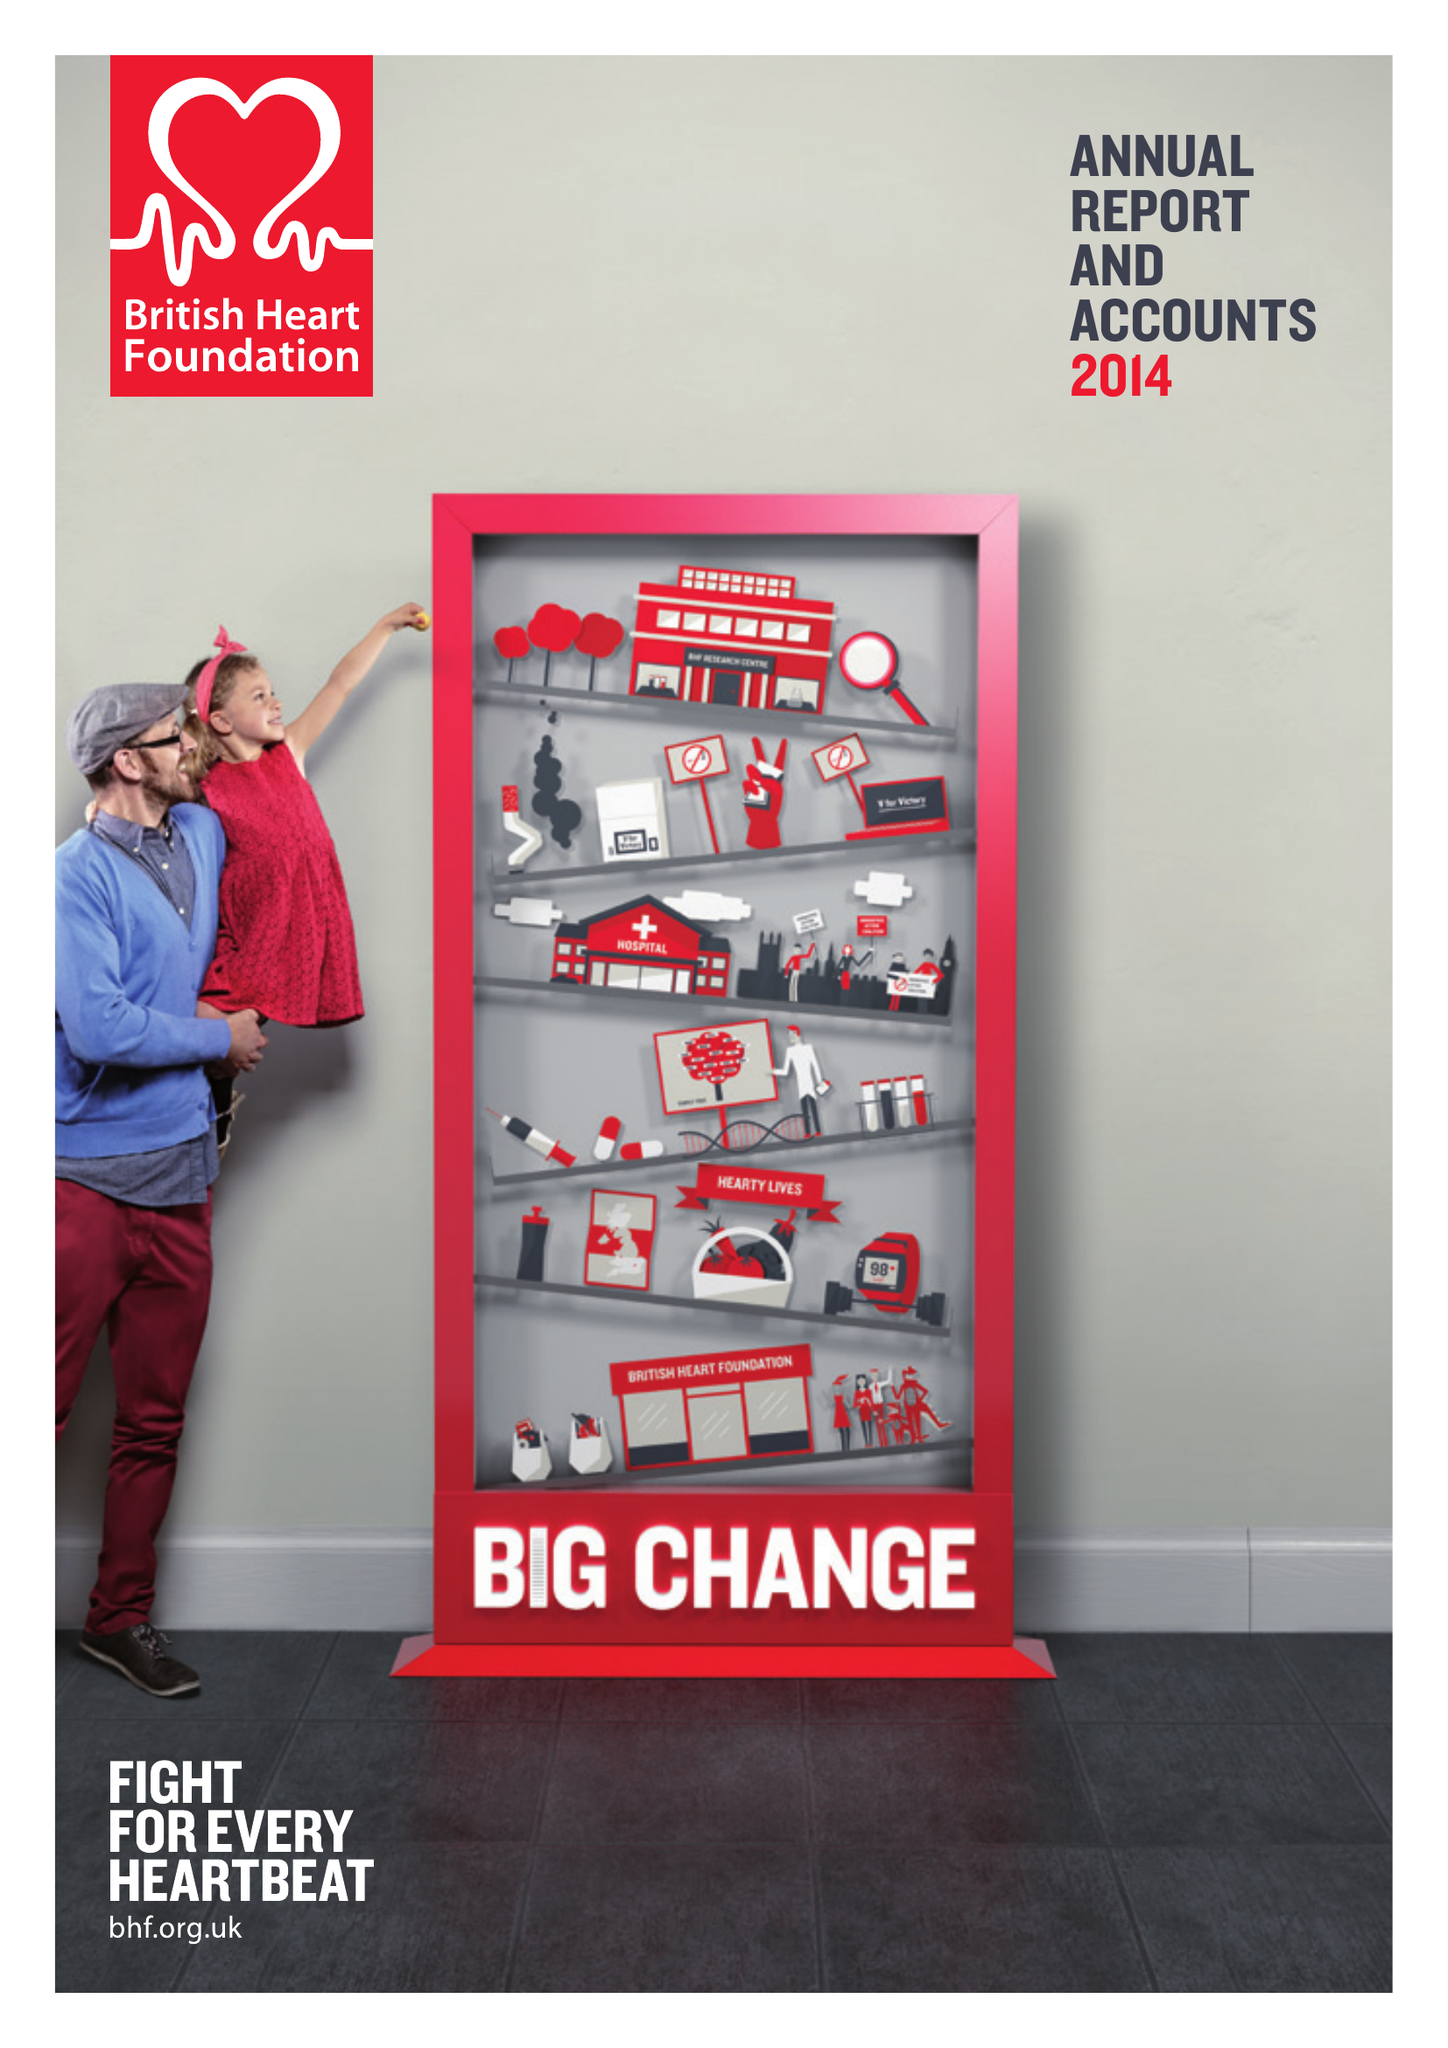What is the value for the address__postcode?
Answer the question using a single word or phrase. NW1 7AW 